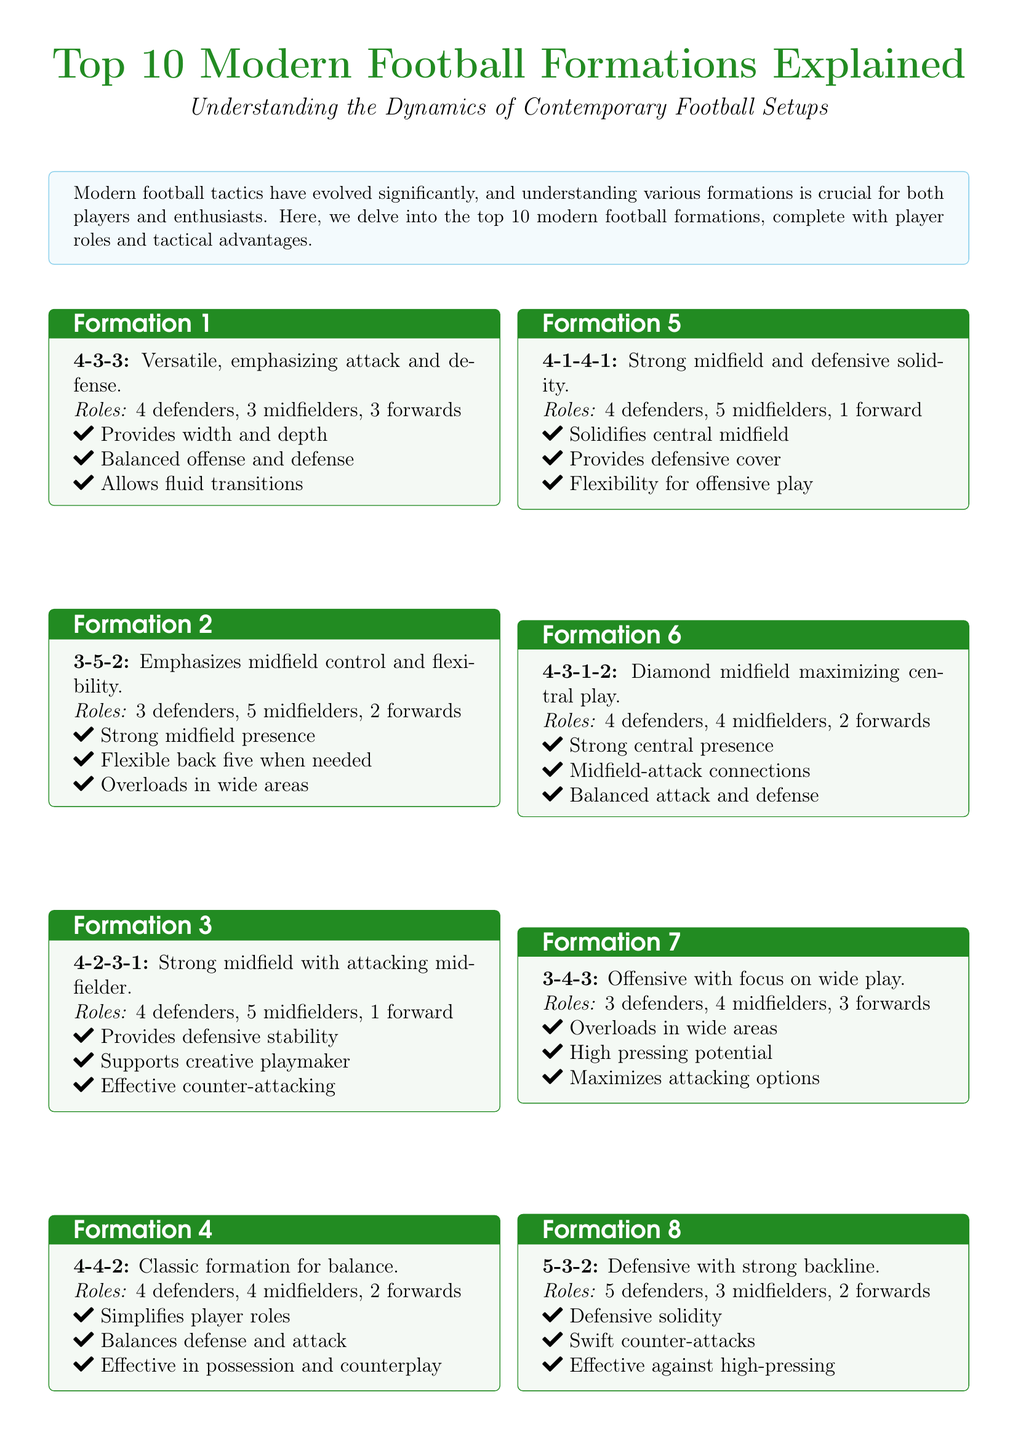What is the first formation listed? The first formation detailed in the flyer is the 4-3-3 formation.
Answer: 4-3-3 How many defenders are used in the 3-5-2 formation? The 3-5-2 formation consists of 3 defenders.
Answer: 3 What is a tactical advantage of the 4-2-3-1 formation? One advantage of the 4-2-3-1 formation is that it provides defensive stability.
Answer: Defensive stability How many total players are involved in the 4-4-2 formation? The 4-4-2 formation includes a total of 10 players on the field.
Answer: 10 Which formation emphasizes a strong backline? The formation that emphasizes a strong backline is the 5-3-2.
Answer: 5-3-2 What role does the 4-1-4-1 formation provide? The 4-1-4-1 formation solidifies central midfield.
Answer: Central midfield What are the roles of players in the 4-2-2-2 formation? The roles in the 4-2-2-2 formation consist of 4 defenders, 4 midfielders, and 2 forwards.
Answer: 4 defenders, 4 midfielders, 2 forwards Which modern formation is known for maximizing central play? The 4-3-1-2 formation is known for maximizing central play.
Answer: 4-3-1-2 What does the 3-4-3 formation maximize? The 3-4-3 formation maximizes attacking options.
Answer: Attacking options 